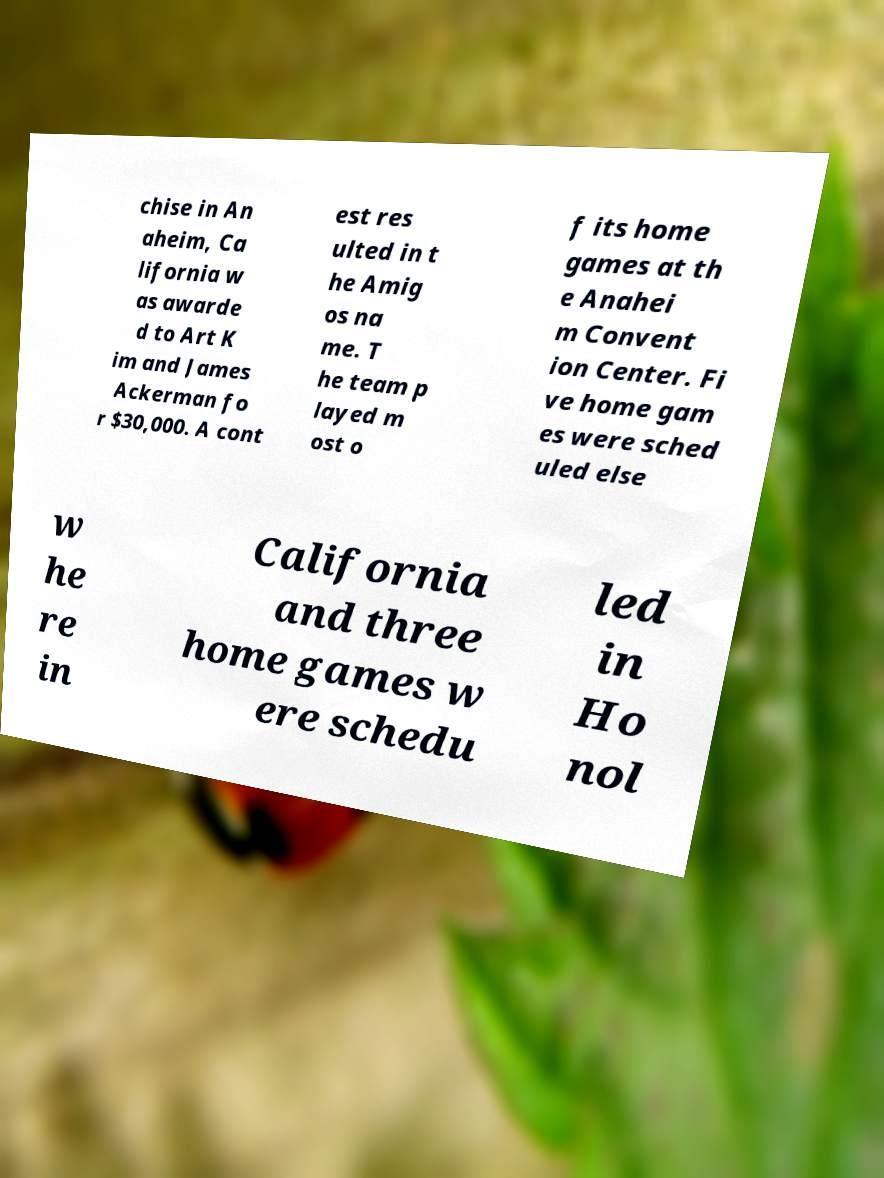Could you extract and type out the text from this image? chise in An aheim, Ca lifornia w as awarde d to Art K im and James Ackerman fo r $30,000. A cont est res ulted in t he Amig os na me. T he team p layed m ost o f its home games at th e Anahei m Convent ion Center. Fi ve home gam es were sched uled else w he re in California and three home games w ere schedu led in Ho nol 